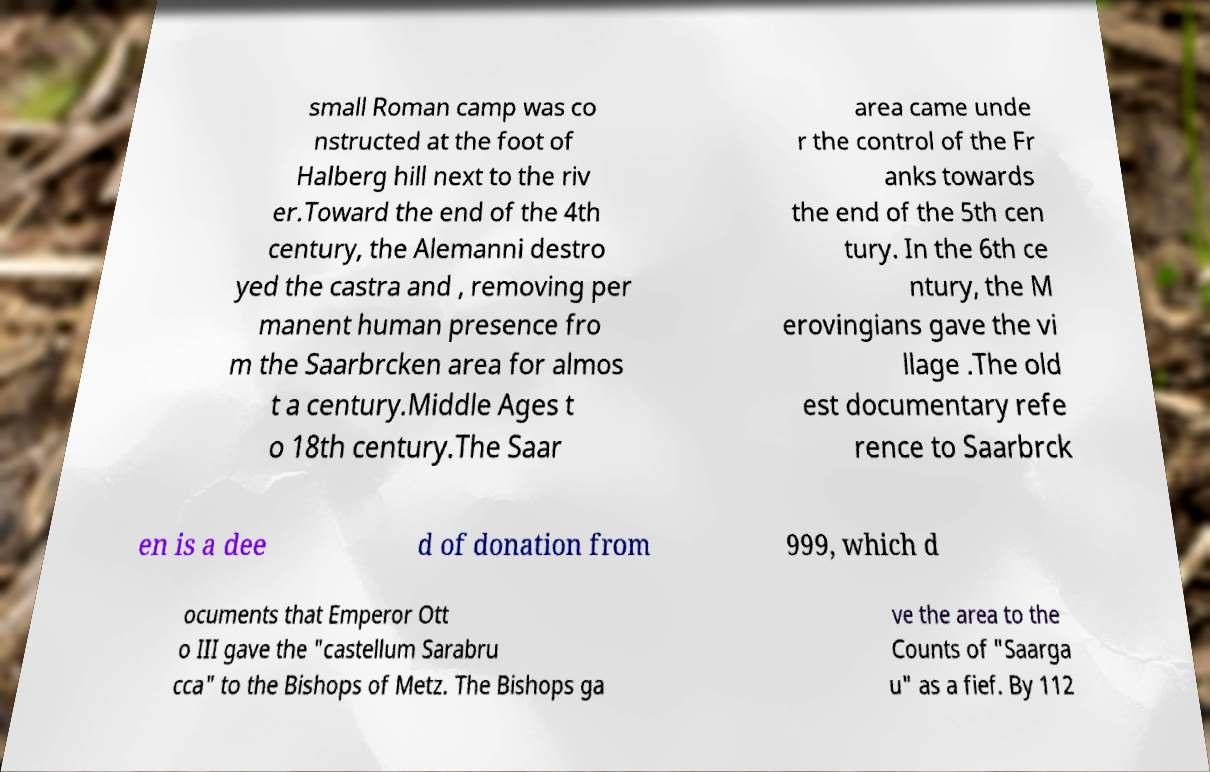For documentation purposes, I need the text within this image transcribed. Could you provide that? small Roman camp was co nstructed at the foot of Halberg hill next to the riv er.Toward the end of the 4th century, the Alemanni destro yed the castra and , removing per manent human presence fro m the Saarbrcken area for almos t a century.Middle Ages t o 18th century.The Saar area came unde r the control of the Fr anks towards the end of the 5th cen tury. In the 6th ce ntury, the M erovingians gave the vi llage .The old est documentary refe rence to Saarbrck en is a dee d of donation from 999, which d ocuments that Emperor Ott o III gave the "castellum Sarabru cca" to the Bishops of Metz. The Bishops ga ve the area to the Counts of "Saarga u" as a fief. By 112 